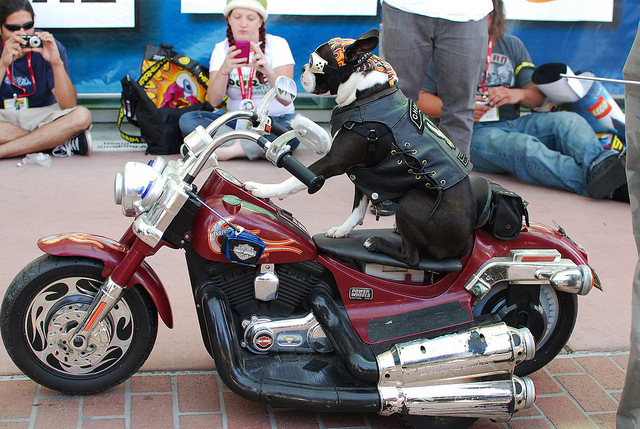<image>What is the dog looking at? It is unknown what the dog is looking at. It might be people, owner or woman with camera. What is the dog looking at? The dog is looking at the people in the image. 